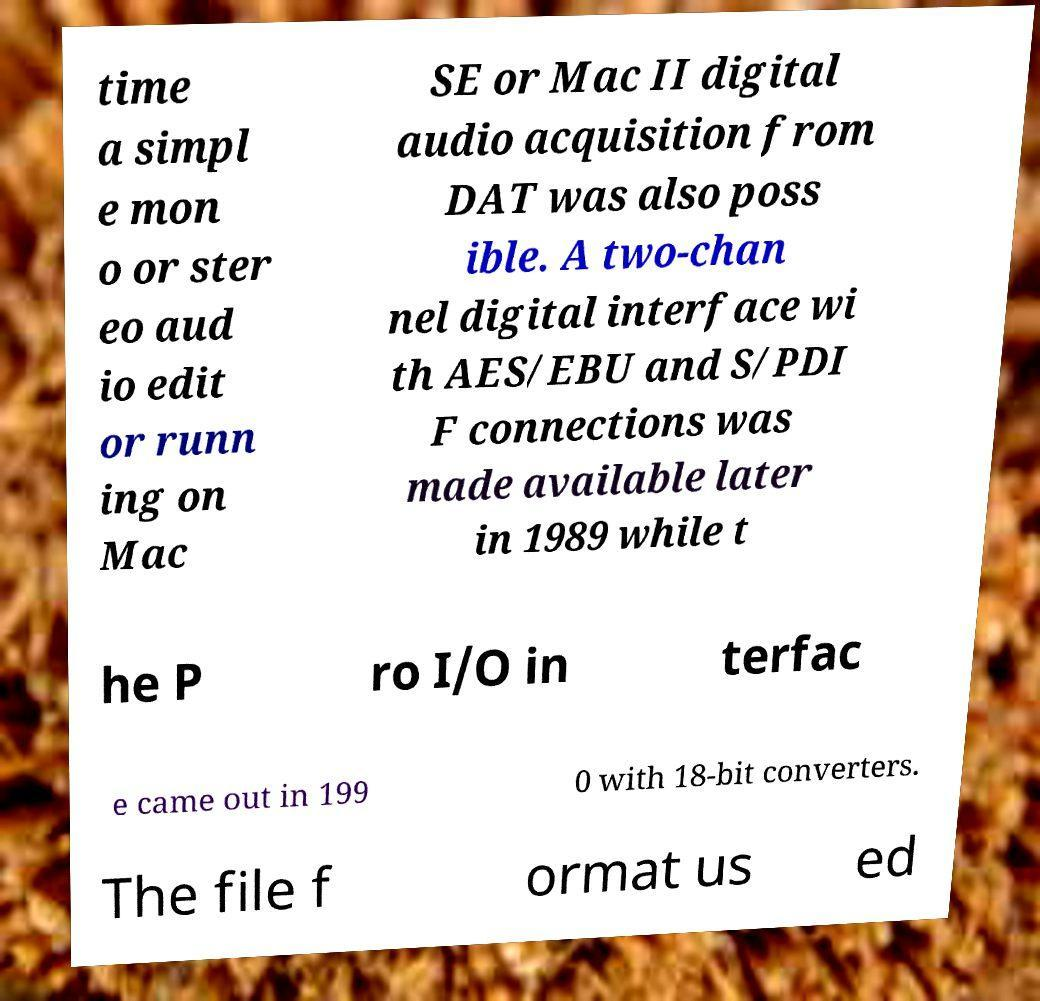What messages or text are displayed in this image? I need them in a readable, typed format. time a simpl e mon o or ster eo aud io edit or runn ing on Mac SE or Mac II digital audio acquisition from DAT was also poss ible. A two-chan nel digital interface wi th AES/EBU and S/PDI F connections was made available later in 1989 while t he P ro I/O in terfac e came out in 199 0 with 18-bit converters. The file f ormat us ed 